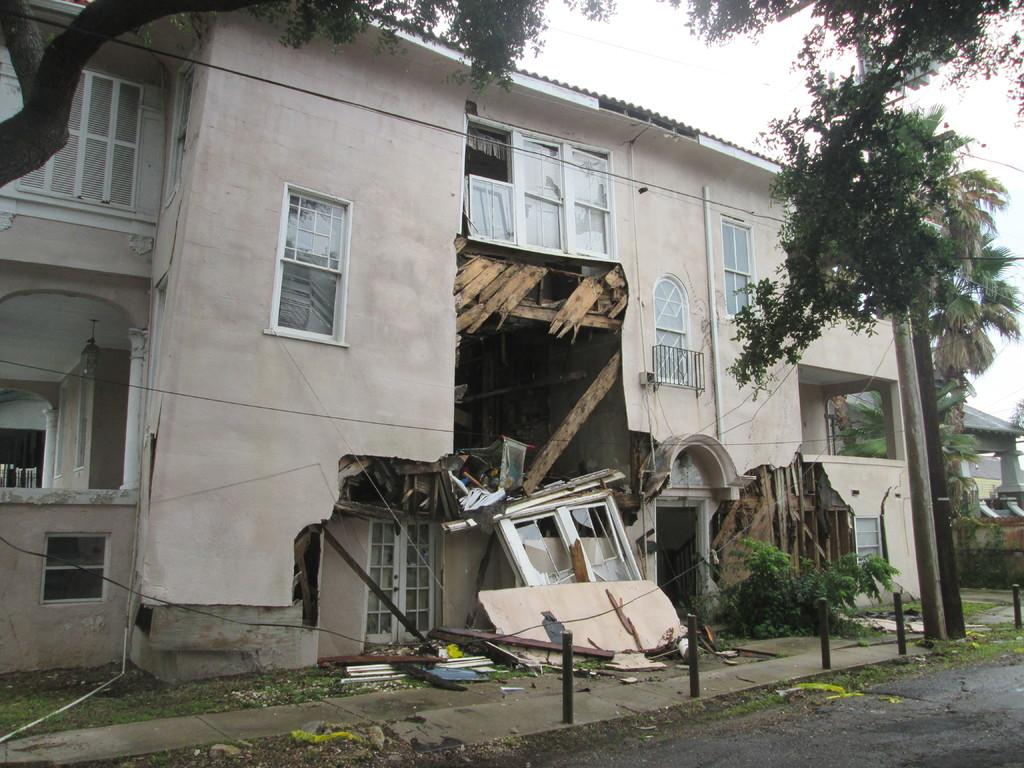What type of vegetation can be seen in the image? There are trees in the image. What is the color of the trees? The trees are green. What is visible in the background of the image? There is a building in the background of the image. What is the color of the building? The building is white. What architectural feature can be seen on the building? There are windows visible on the building. What is the color of the sky in the image? The sky is white in the image. How many ducks are sleeping under the flower in the image? There are no ducks or flowers present in the image. 